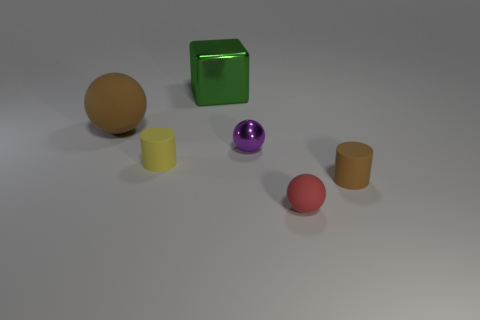What is the size of the red object that is the same shape as the purple object?
Offer a terse response. Small. What color is the large rubber thing that is the same shape as the purple metallic object?
Your answer should be compact. Brown. How many shiny objects are both in front of the green metallic thing and behind the large brown sphere?
Make the answer very short. 0. Is the number of small cyan matte cylinders greater than the number of rubber objects?
Your response must be concise. No. What is the material of the red object?
Keep it short and to the point. Rubber. What number of tiny cylinders are behind the small matte cylinder that is behind the small brown cylinder?
Your answer should be very brief. 0. Do the tiny shiny sphere and the matte cylinder left of the large green block have the same color?
Offer a very short reply. No. What is the color of the metallic thing that is the same size as the brown cylinder?
Your answer should be compact. Purple. Are there any yellow things of the same shape as the tiny brown object?
Keep it short and to the point. Yes. Are there fewer brown metallic cylinders than brown cylinders?
Your answer should be very brief. Yes. 